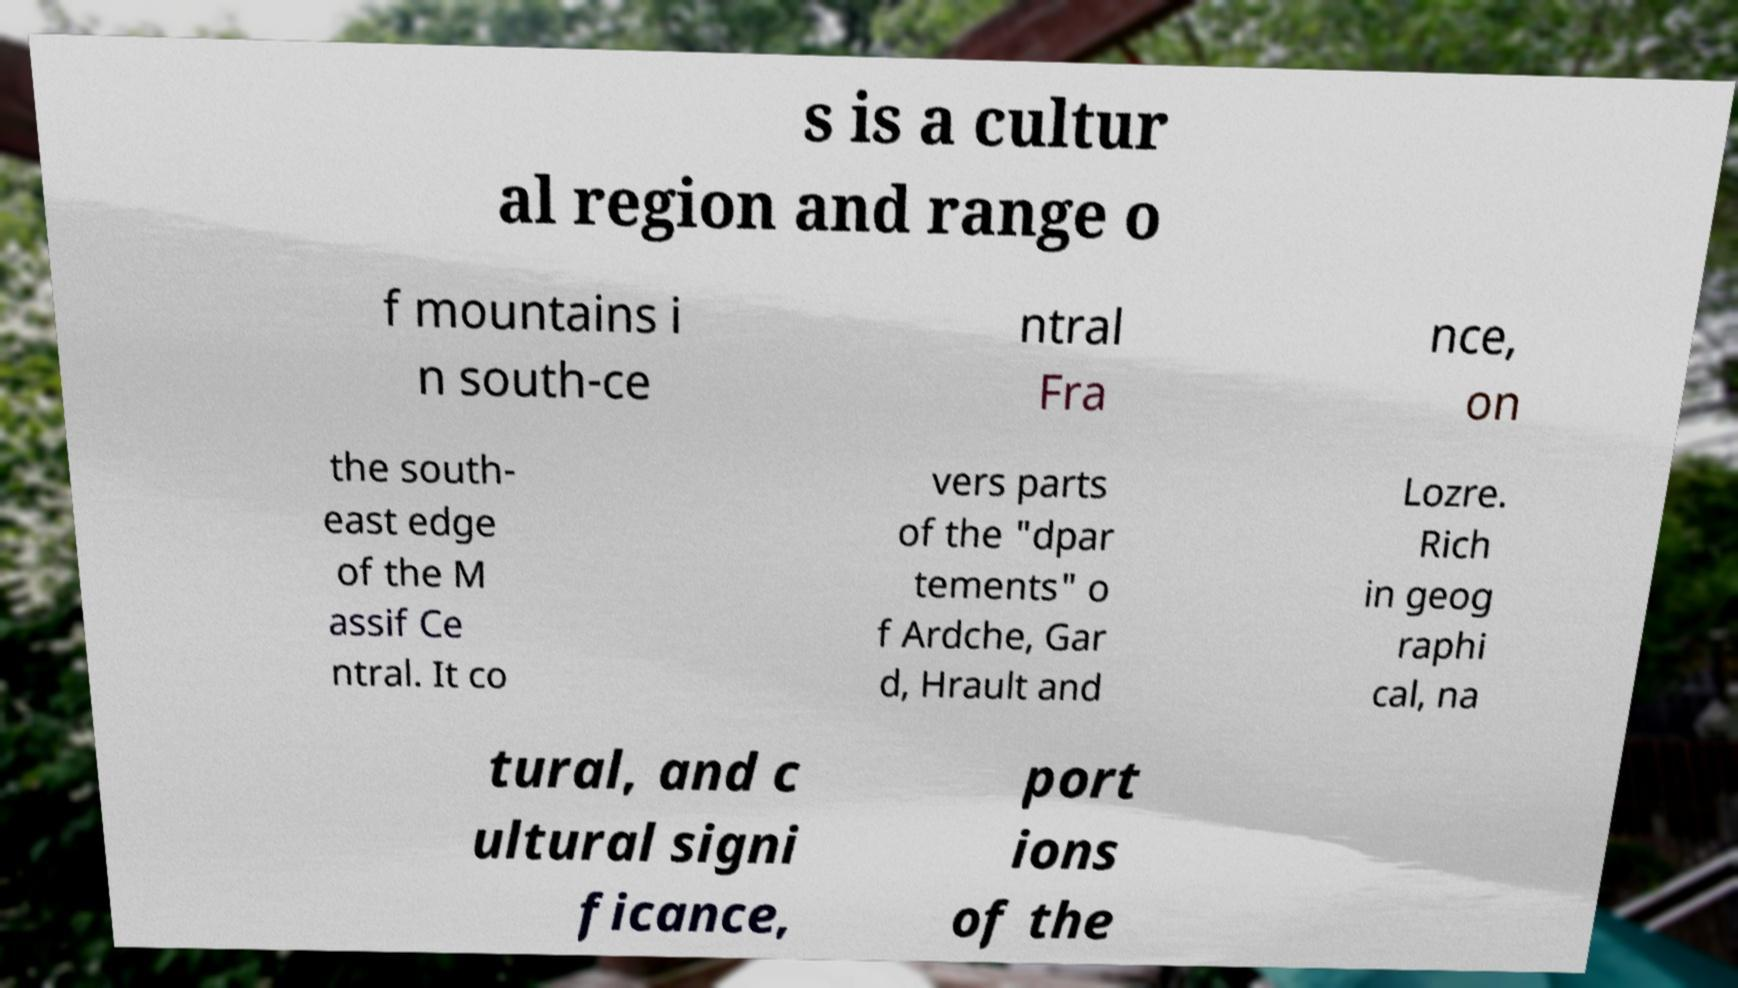Could you extract and type out the text from this image? s is a cultur al region and range o f mountains i n south-ce ntral Fra nce, on the south- east edge of the M assif Ce ntral. It co vers parts of the "dpar tements" o f Ardche, Gar d, Hrault and Lozre. Rich in geog raphi cal, na tural, and c ultural signi ficance, port ions of the 